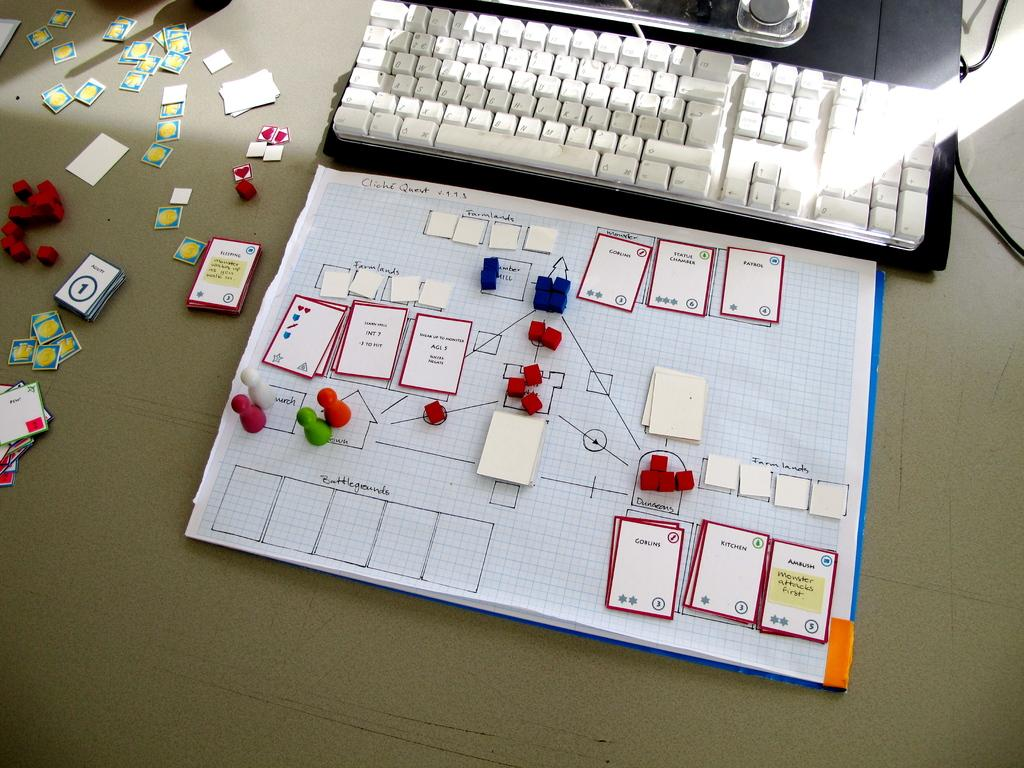What electronic device is visible in the image? There is a laptop in the image. What type of paper items are present in the image? There are papers in the image. What other objects can be seen in the image? There are cards and wires visible in the image. Can you describe the setting where the image was taken? The image may have been taken in a room, but the specific location is not clear from the provided facts. How many words can be seen on the laptop screen in the image? There is no information about the content on the laptop screen, so it is not possible to determine the number of words visible. 